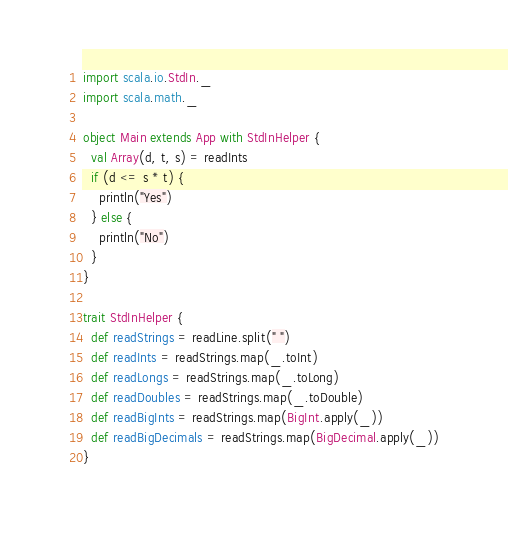<code> <loc_0><loc_0><loc_500><loc_500><_Scala_>import scala.io.StdIn._
import scala.math._

object Main extends App with StdInHelper {
  val Array(d, t, s) = readInts
  if (d <= s * t) {
    println("Yes")
  } else {
    println("No")
  }
}

trait StdInHelper {
  def readStrings = readLine.split(" ")
  def readInts = readStrings.map(_.toInt)
  def readLongs = readStrings.map(_.toLong)
  def readDoubles = readStrings.map(_.toDouble)
  def readBigInts = readStrings.map(BigInt.apply(_))
  def readBigDecimals = readStrings.map(BigDecimal.apply(_))
}
</code> 